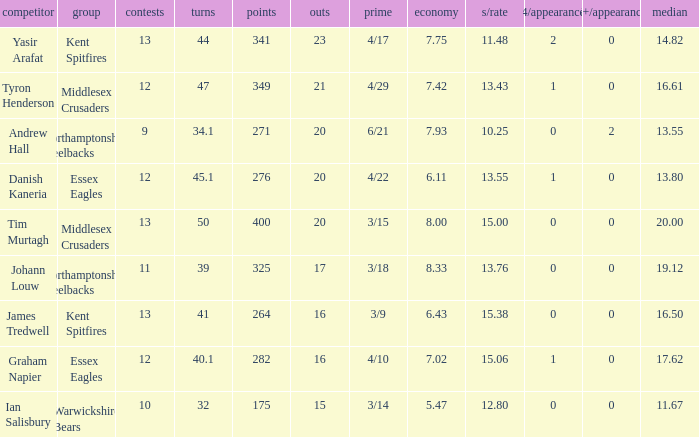Name the matches for wickets 17 11.0. 